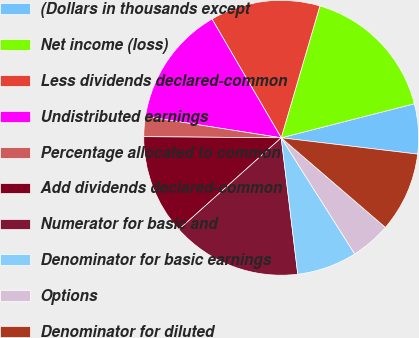<chart> <loc_0><loc_0><loc_500><loc_500><pie_chart><fcel>(Dollars in thousands except<fcel>Net income (loss)<fcel>Less dividends declared-common<fcel>Undistributed earnings<fcel>Percentage allocated to common<fcel>Add dividends declared-common<fcel>Numerator for basic and<fcel>Denominator for basic earnings<fcel>Options<fcel>Denominator for diluted<nl><fcel>5.88%<fcel>16.47%<fcel>12.94%<fcel>14.12%<fcel>2.35%<fcel>11.76%<fcel>15.29%<fcel>7.06%<fcel>4.71%<fcel>9.41%<nl></chart> 